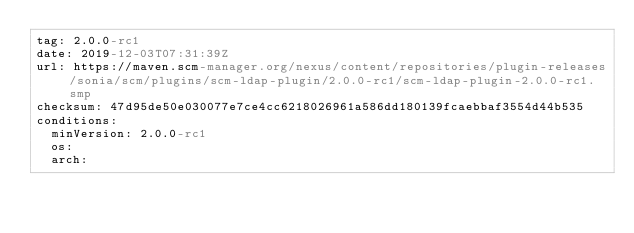Convert code to text. <code><loc_0><loc_0><loc_500><loc_500><_YAML_>tag: 2.0.0-rc1
date: 2019-12-03T07:31:39Z
url: https://maven.scm-manager.org/nexus/content/repositories/plugin-releases/sonia/scm/plugins/scm-ldap-plugin/2.0.0-rc1/scm-ldap-plugin-2.0.0-rc1.smp
checksum: 47d95de50e030077e7ce4cc6218026961a586dd180139fcaebbaf3554d44b535
conditions:
  minVersion: 2.0.0-rc1
  os:
  arch: 
  </code> 